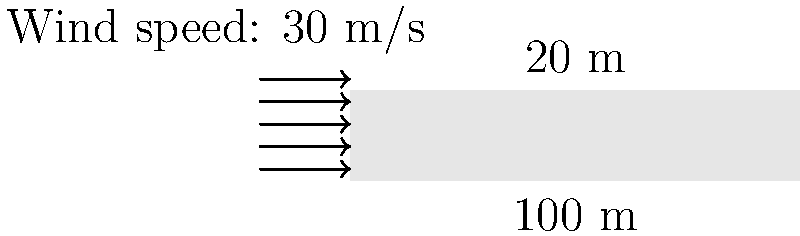For an open-air fashion party, you're planning to use a large fabric canopy structure. The rectangular canopy measures 100 m long and 20 m wide. If the wind speed is 30 m/s and the drag coefficient for the fabric is 1.2, what is the total wind load on the canopy in kilonewtons (kN)? Assume air density is 1.225 kg/m³ and the wind direction is perpendicular to the long side of the canopy. To calculate the wind load on the canopy, we'll use the following steps:

1. Calculate the area of the canopy:
   $A = 100 \text{ m} \times 20 \text{ m} = 2000 \text{ m}^2$

2. Use the wind load formula:
   $F = \frac{1}{2} \rho v^2 C_d A$

   Where:
   $F$ = wind force (N)
   $\rho$ = air density (kg/m³)
   $v$ = wind speed (m/s)
   $C_d$ = drag coefficient
   $A$ = area (m²)

3. Plug in the values:
   $F = \frac{1}{2} \times 1.225 \text{ kg/m}^3 \times (30 \text{ m/s})^2 \times 1.2 \times 2000 \text{ m}^2$

4. Calculate:
   $F = 0.5 \times 1.225 \times 900 \times 1.2 \times 2000$
   $F = 1,323,000 \text{ N}$

5. Convert to kilonewtons:
   $F = 1,323,000 \text{ N} \times \frac{1 \text{ kN}}{1000 \text{ N}} = 1,323 \text{ kN}$

Therefore, the total wind load on the canopy is 1,323 kN.
Answer: 1,323 kN 